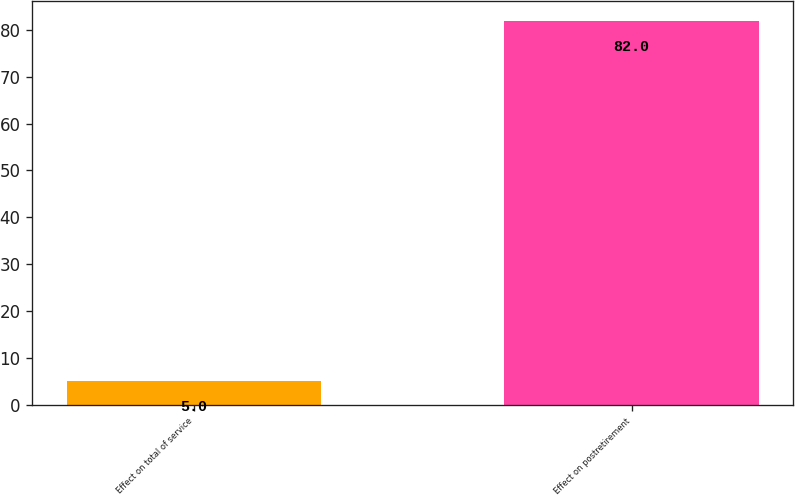<chart> <loc_0><loc_0><loc_500><loc_500><bar_chart><fcel>Effect on total of service<fcel>Effect on postretirement<nl><fcel>5<fcel>82<nl></chart> 